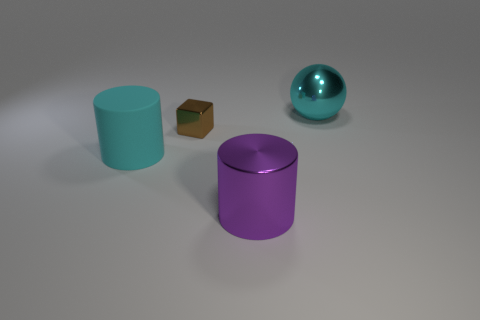Add 4 purple objects. How many objects exist? 8 Subtract all balls. How many objects are left? 3 Subtract 0 yellow balls. How many objects are left? 4 Subtract all big cylinders. Subtract all purple objects. How many objects are left? 1 Add 2 rubber cylinders. How many rubber cylinders are left? 3 Add 3 big cyan cylinders. How many big cyan cylinders exist? 4 